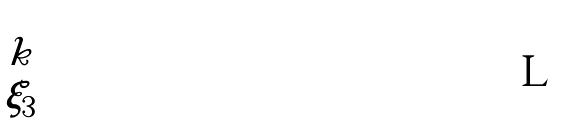Convert formula to latex. <formula><loc_0><loc_0><loc_500><loc_500>\begin{bmatrix} k \\ \xi _ { 3 } \end{bmatrix}</formula> 